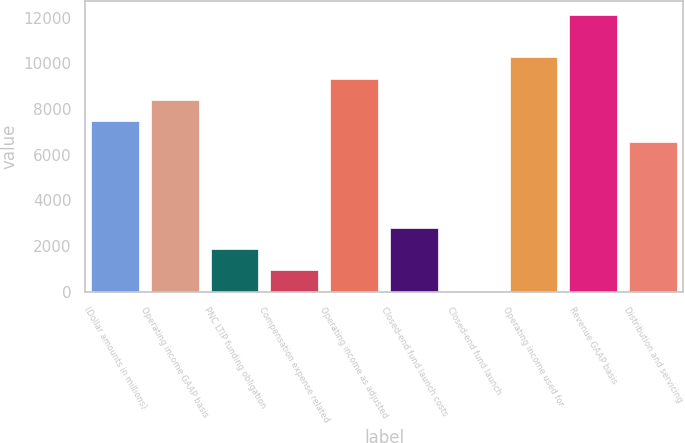Convert chart. <chart><loc_0><loc_0><loc_500><loc_500><bar_chart><fcel>(Dollar amounts in millions)<fcel>Operating income GAAP basis<fcel>PNC LTIP funding obligation<fcel>Compensation expense related<fcel>Operating income as adjusted<fcel>Closed-end fund launch costs<fcel>Closed-end fund launch<fcel>Operating income used for<fcel>Revenue GAAP basis<fcel>Distribution and servicing<nl><fcel>7470.2<fcel>8403.6<fcel>1869.8<fcel>936.4<fcel>9337<fcel>2803.2<fcel>3<fcel>10270.4<fcel>12137.2<fcel>6536.8<nl></chart> 